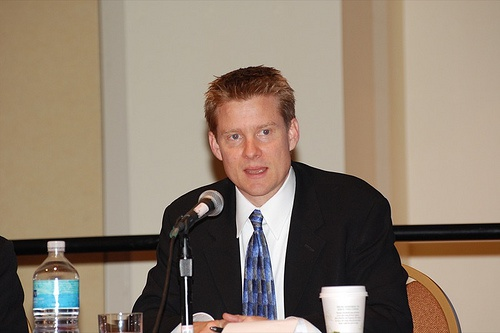Describe the objects in this image and their specific colors. I can see people in gray, black, white, brown, and salmon tones, bottle in gray, lightblue, and white tones, tie in gray, navy, and black tones, chair in gray, brown, salmon, and maroon tones, and cup in gray, white, black, and darkgray tones in this image. 